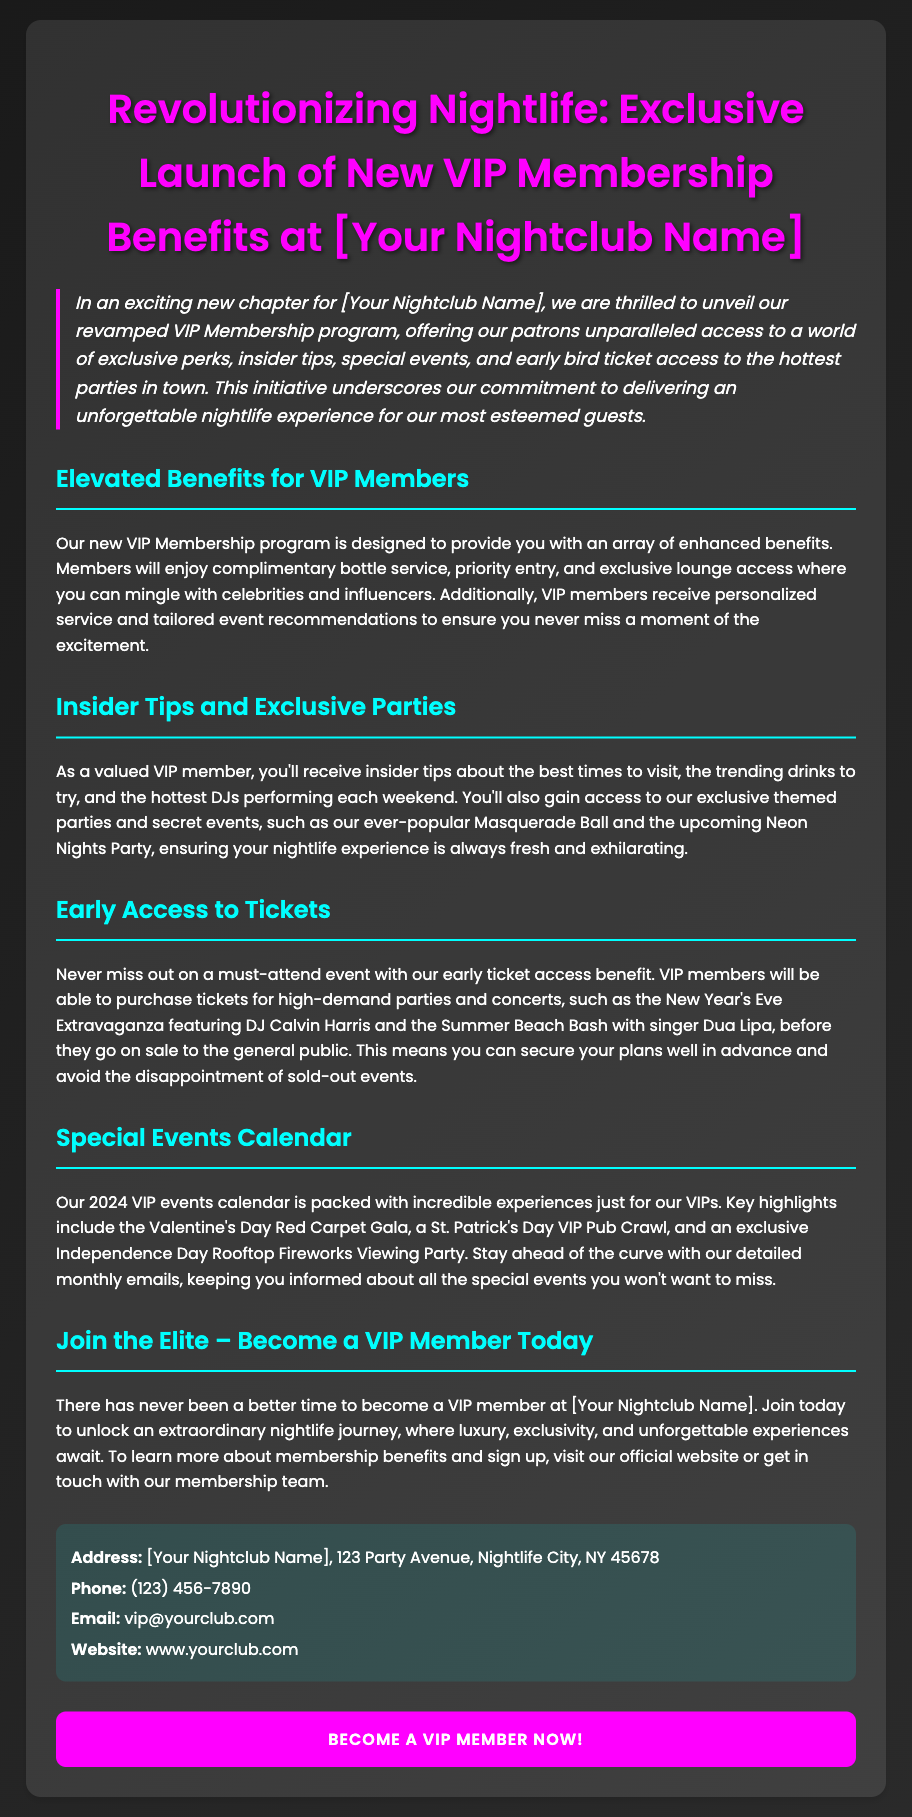What is the title of the press release? The title of the press release is prominently displayed at the top and summarizes the main announcement.
Answer: Revolutionizing Nightlife: Exclusive Launch of New VIP Membership Benefits at [Your Nightclub Name] What are VIP members promised in terms of entry? The document mentions a specific benefit related to entry for VIP members, highlighting their priority over non-VIP members.
Answer: Priority entry What special events are highlighted for VIP members? The document lists specific events that will be exclusive to VIP members, showcasing the unique experiences they can have.
Answer: Valentine's Day Red Carpet Gala Who can be contacted for more information? The document includes contact information for inquiries, indicating who to reach out to for further details.
Answer: vip@yourclub.com What is one benefit of the VIP membership? The benefits of the VIP membership are detailed throughout the document, pointing to unique experiences for members.
Answer: Complimentary bottle service What is the upcoming party featuring DJ Calvin Harris? The press release specifies a major event with a well-known artist, showing the type of entertainment VIP members can expect.
Answer: New Year's Eve Extravaganza 